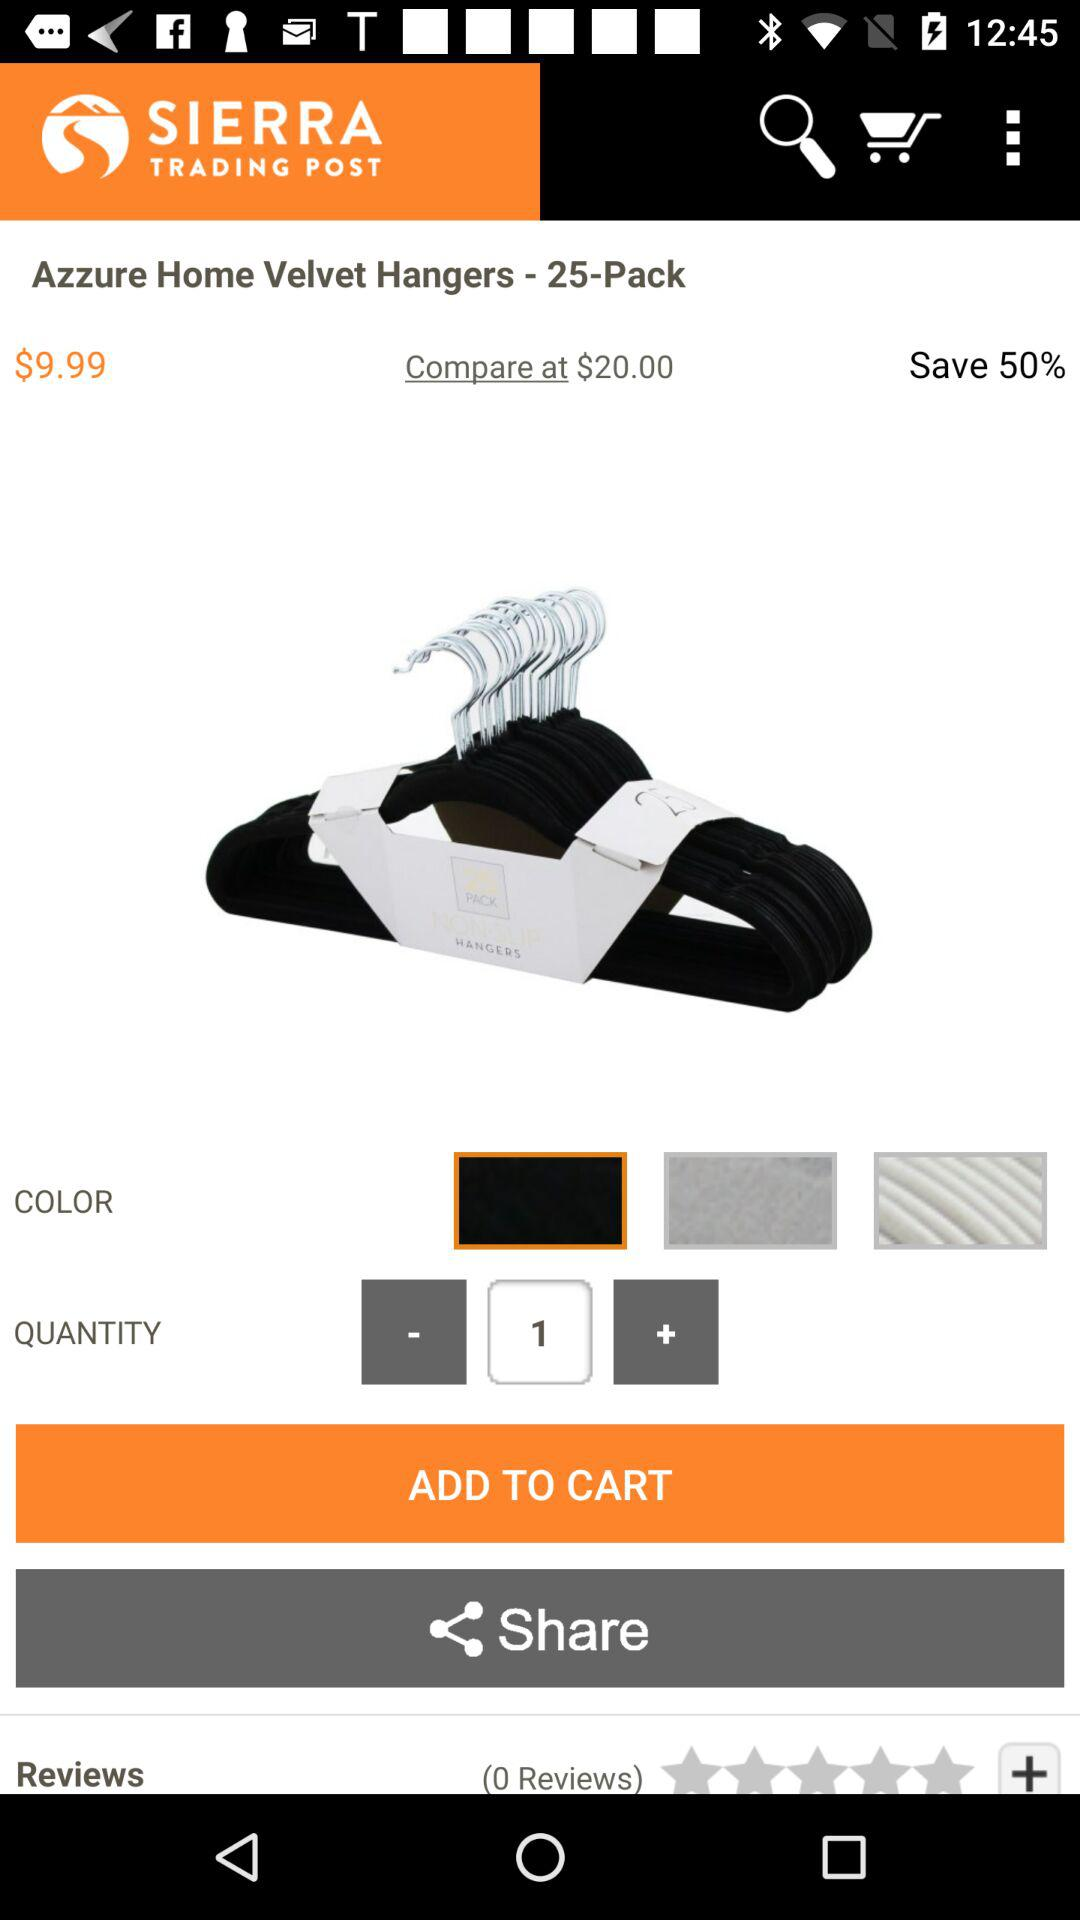How many reviews in total are there? There are 0 reviews in total. 